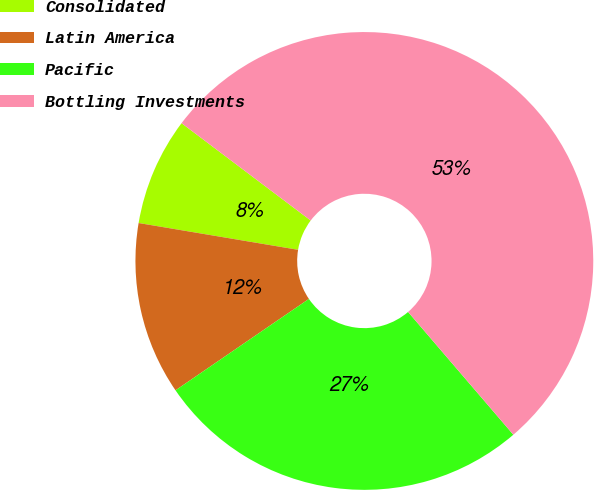<chart> <loc_0><loc_0><loc_500><loc_500><pie_chart><fcel>Consolidated<fcel>Latin America<fcel>Pacific<fcel>Bottling Investments<nl><fcel>7.63%<fcel>12.21%<fcel>26.72%<fcel>53.44%<nl></chart> 